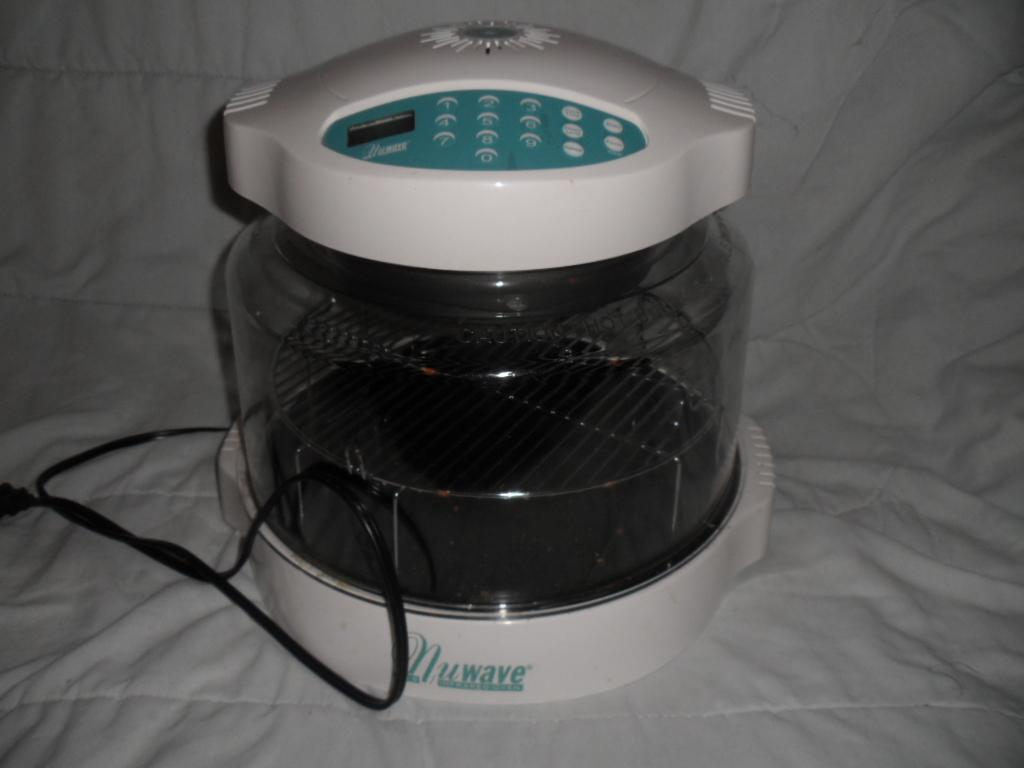What is the main object in the image? There is a device in the image. What feature does the device have? The device has a wire. What is the color of the sheet the device is placed on? The device is on a white color sheet. Can you see the pig requesting approval from the device in the image? There is no pig present in the image, nor is there any indication of a request or approval being made. 